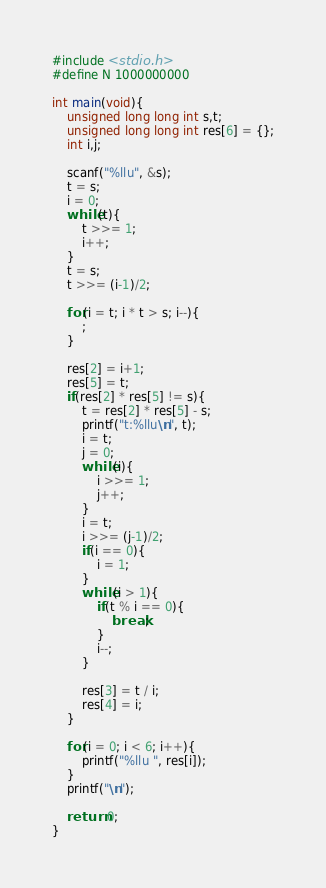<code> <loc_0><loc_0><loc_500><loc_500><_C_>#include <stdio.h>
#define N 1000000000

int main(void){
    unsigned long long int s,t;
    unsigned long long int res[6] = {};
    int i,j;
    
    scanf("%llu", &s);
    t = s;
    i = 0;
    while(t){
        t >>= 1;
        i++;
    }
    t = s;
    t >>= (i-1)/2;
    
    for(i = t; i * t > s; i--){
        ;
    }
    
    res[2] = i+1;
    res[5] = t;
    if(res[2] * res[5] != s){
        t = res[2] * res[5] - s;
        printf("t:%llu\n", t);
        i = t;
        j = 0;
        while(i){
            i >>= 1;
            j++;
        }
        i = t;
        i >>= (j-1)/2;
        if(i == 0){
            i = 1;
        }
        while(i > 1){
            if(t % i == 0){
                break;
            }
            i--;
        }
        
        res[3] = t / i;
        res[4] = i;
    }
    
    for(i = 0; i < 6; i++){
        printf("%llu ", res[i]);
    }
    printf("\n");
    
    return 0;
}</code> 